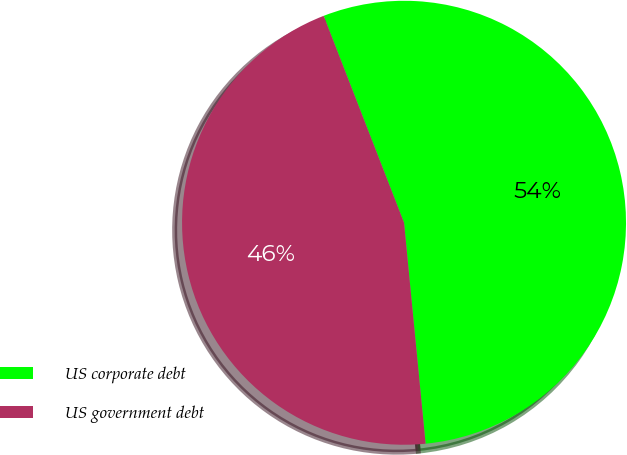Convert chart. <chart><loc_0><loc_0><loc_500><loc_500><pie_chart><fcel>US corporate debt<fcel>US government debt<nl><fcel>54.35%<fcel>45.65%<nl></chart> 